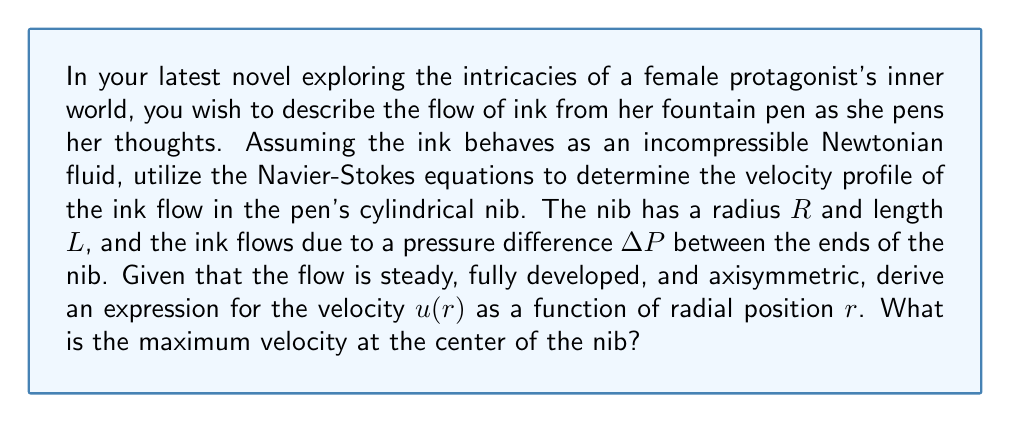Could you help me with this problem? Let's approach this problem step-by-step, using the Navier-Stokes equations for incompressible flow:

1) For steady, fully developed, axisymmetric flow in a cylinder, the Navier-Stokes equation in cylindrical coordinates reduces to:

   $$\frac{1}{r}\frac{d}{dr}\left(r\frac{du}{dr}\right) = \frac{1}{\mu}\frac{dP}{dx}$$

   where $\mu$ is the dynamic viscosity of the ink, and $\frac{dP}{dx}$ is the pressure gradient along the nib.

2) The pressure gradient is constant and can be expressed as:

   $$\frac{dP}{dx} = -\frac{\Delta P}{L}$$

3) Integrating the equation once with respect to $r$:

   $$r\frac{du}{dr} = -\frac{r}{2\mu}\frac{\Delta P}{L} + C_1$$

4) Integrating again:

   $$u(r) = -\frac{1}{4\mu}\frac{\Delta P}{L}r^2 + C_1\ln(r) + C_2$$

5) To determine the constants, we use the boundary conditions:
   - At $r = R$, $u = 0$ (no-slip condition at the wall)
   - At $r = 0$, $\frac{du}{dr} = 0$ (axisymmetry condition)

6) Applying the second condition to the first integral:

   $$0 = -\frac{0}{2\mu}\frac{\Delta P}{L} + C_1 \implies C_1 = 0$$

7) Applying the first condition to the velocity equation:

   $$0 = -\frac{1}{4\mu}\frac{\Delta P}{L}R^2 + C_2 \implies C_2 = \frac{1}{4\mu}\frac{\Delta P}{L}R^2$$

8) Therefore, the velocity profile is:

   $$u(r) = \frac{\Delta P}{4\mu L}(R^2 - r^2)$$

9) The maximum velocity occurs at the center ($r = 0$):

   $$u_{max} = u(0) = \frac{\Delta P}{4\mu L}R^2$$

This parabolic velocity profile is characteristic of laminar flow in a pipe, known as Poiseuille flow.
Answer: The velocity profile of the ink flow in the cylindrical nib is given by:

$$u(r) = \frac{\Delta P}{4\mu L}(R^2 - r^2)$$

The maximum velocity at the center of the nib ($r = 0$) is:

$$u_{max} = \frac{\Delta P}{4\mu L}R^2$$ 